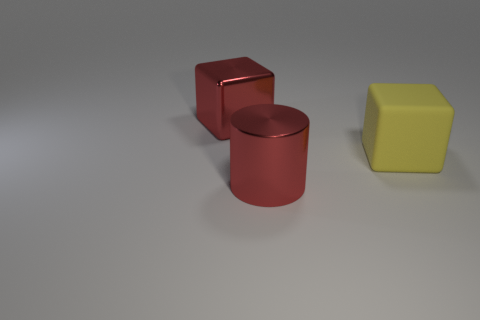Are there any other things that are made of the same material as the large yellow cube?
Ensure brevity in your answer.  No. Are there any other large yellow matte things of the same shape as the rubber object?
Provide a succinct answer. No. Are there the same number of large yellow matte cubes right of the yellow matte object and red things that are to the left of the big red metal cylinder?
Offer a terse response. No. There is a big red metallic object that is in front of the big matte thing; is it the same shape as the rubber thing?
Make the answer very short. No. What number of matte objects are red cylinders or big cyan spheres?
Your answer should be very brief. 0. There is a large cylinder that is the same color as the shiny cube; what is it made of?
Offer a very short reply. Metal. Does the metallic block have the same size as the yellow matte object?
Offer a terse response. Yes. How many things are big yellow rubber cubes or yellow matte things to the right of the red shiny cube?
Offer a terse response. 1. There is another block that is the same size as the matte cube; what material is it?
Your answer should be very brief. Metal. There is a large object that is in front of the red block and behind the large red metallic cylinder; what is its material?
Provide a succinct answer. Rubber. 